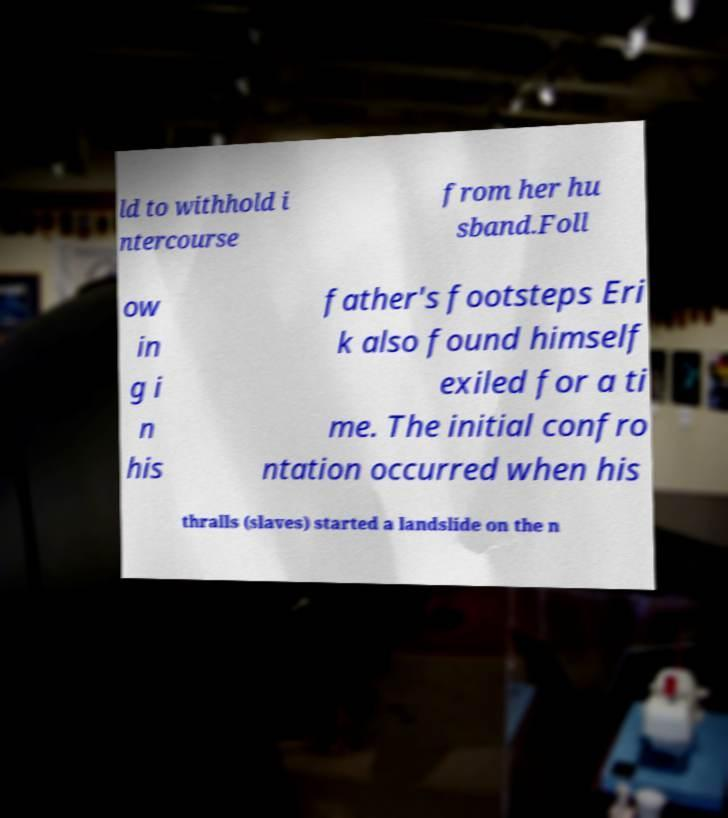Please identify and transcribe the text found in this image. ld to withhold i ntercourse from her hu sband.Foll ow in g i n his father's footsteps Eri k also found himself exiled for a ti me. The initial confro ntation occurred when his thralls (slaves) started a landslide on the n 